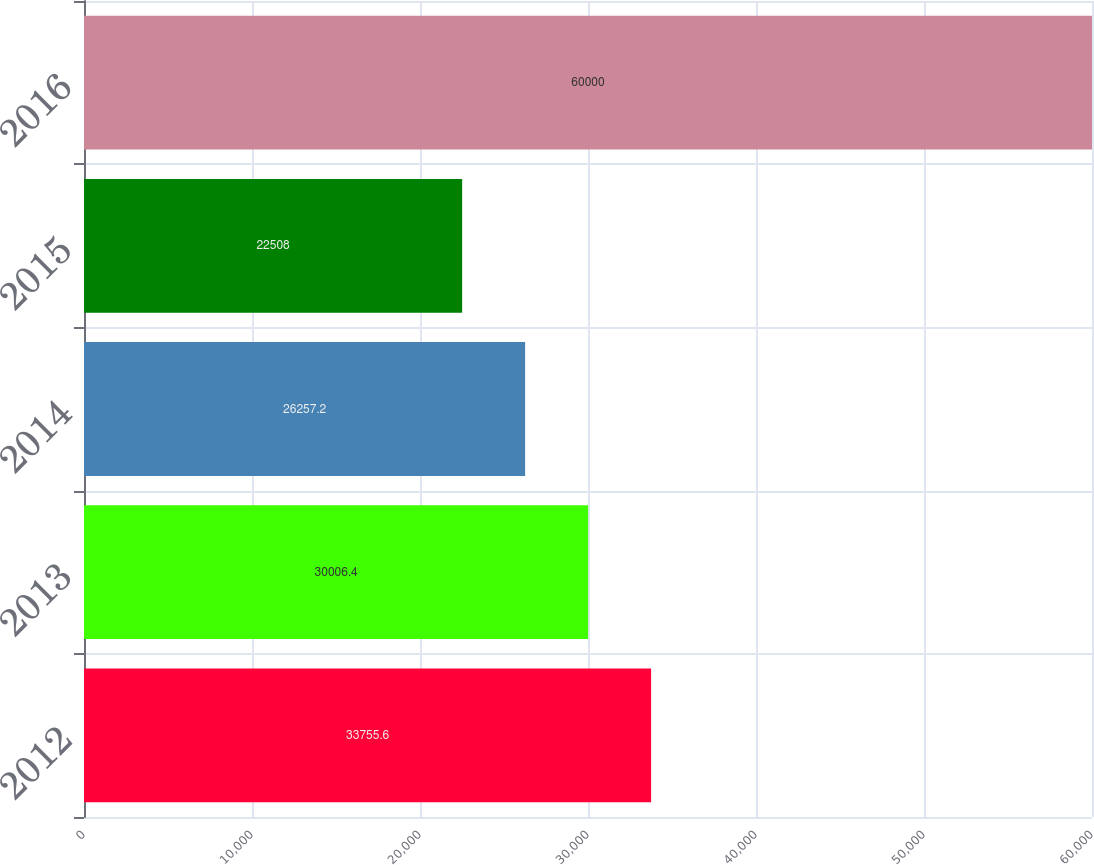Convert chart. <chart><loc_0><loc_0><loc_500><loc_500><bar_chart><fcel>2012<fcel>2013<fcel>2014<fcel>2015<fcel>2016<nl><fcel>33755.6<fcel>30006.4<fcel>26257.2<fcel>22508<fcel>60000<nl></chart> 